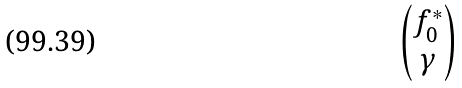<formula> <loc_0><loc_0><loc_500><loc_500>\begin{pmatrix} f _ { 0 } ^ { * } \\ \gamma \end{pmatrix}</formula> 